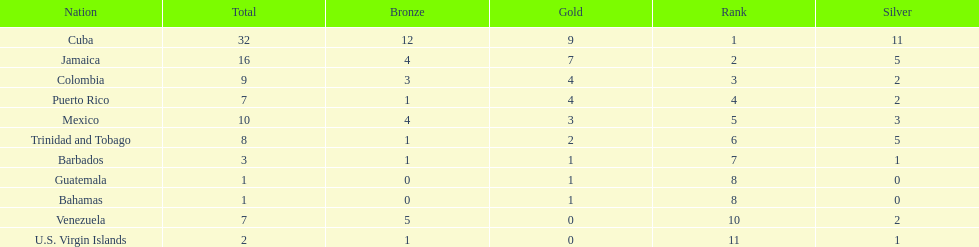Which team had four gold models and one bronze medal? Puerto Rico. 